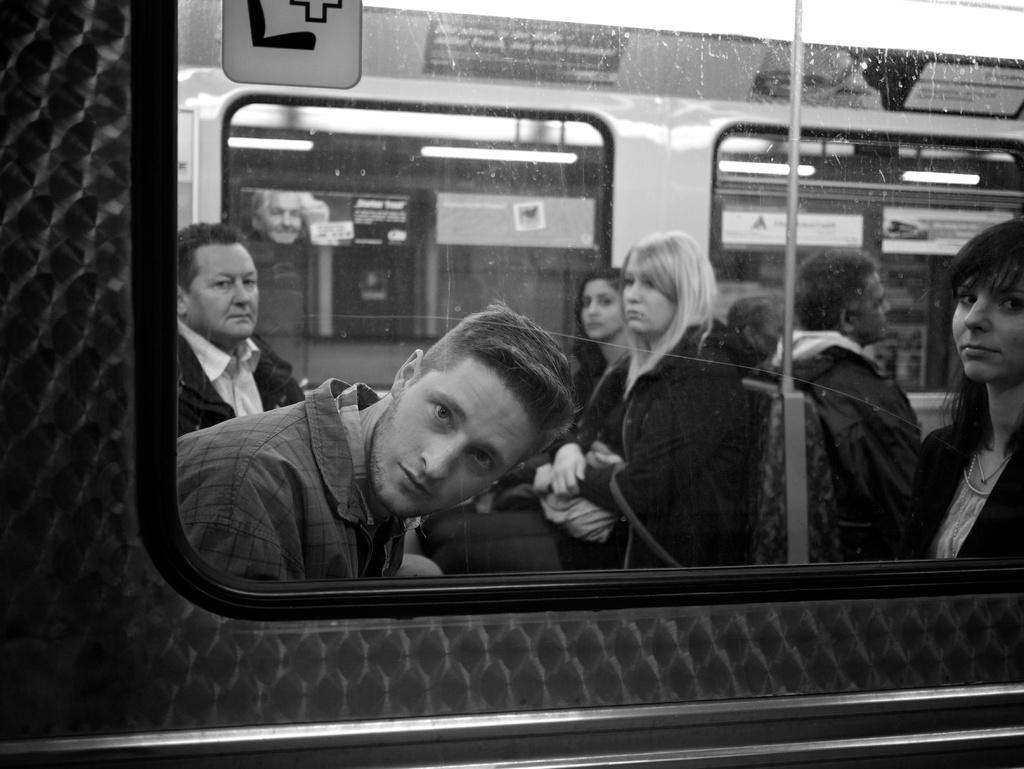What is the color scheme of the image? The image is black and white. What can be seen in the image besides the color scheme? There is a vehicle, persons sitting in the vehicle, a pole, lights, and a board in the image. Is there a paper blowing in the wind during the rainstorm in the image? There is no rainstorm or paper present in the image. Can you see an arm reaching out from the vehicle in the image? The image does not show any arms or persons reaching out from the vehicle. 